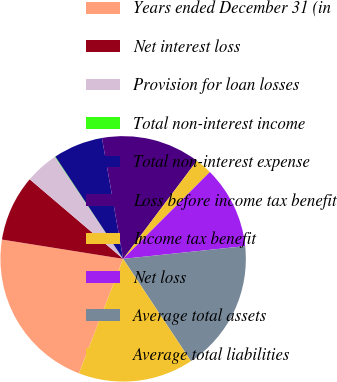Convert chart to OTSL. <chart><loc_0><loc_0><loc_500><loc_500><pie_chart><fcel>Years ended December 31 (in<fcel>Net interest loss<fcel>Provision for loan losses<fcel>Total non-interest income<fcel>Total non-interest expense<fcel>Loss before income tax benefit<fcel>Income tax benefit<fcel>Net loss<fcel>Average total assets<fcel>Average total liabilities<nl><fcel>21.65%<fcel>8.71%<fcel>4.39%<fcel>0.07%<fcel>6.55%<fcel>13.02%<fcel>2.23%<fcel>10.86%<fcel>17.34%<fcel>15.18%<nl></chart> 